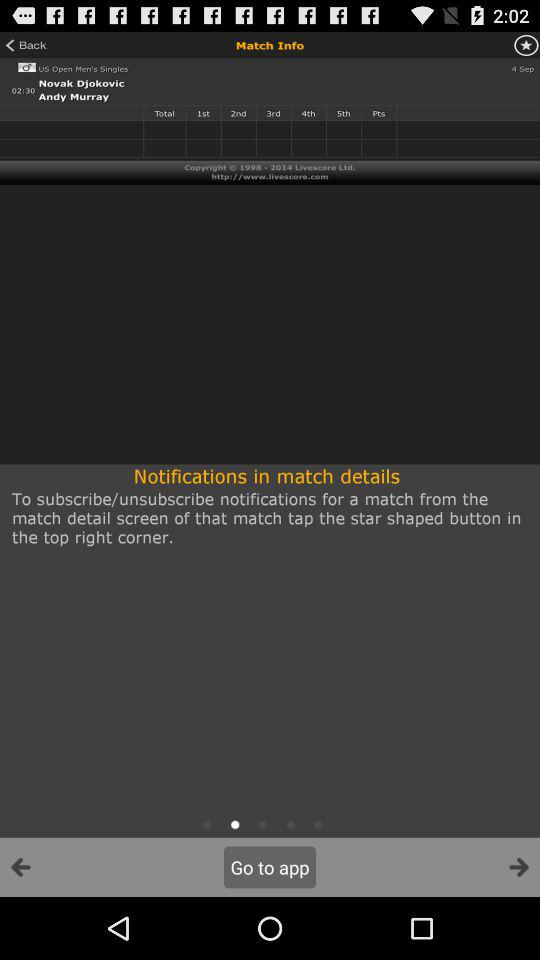What is the name of the match? The name of the match is "US Open Men's Singles". 